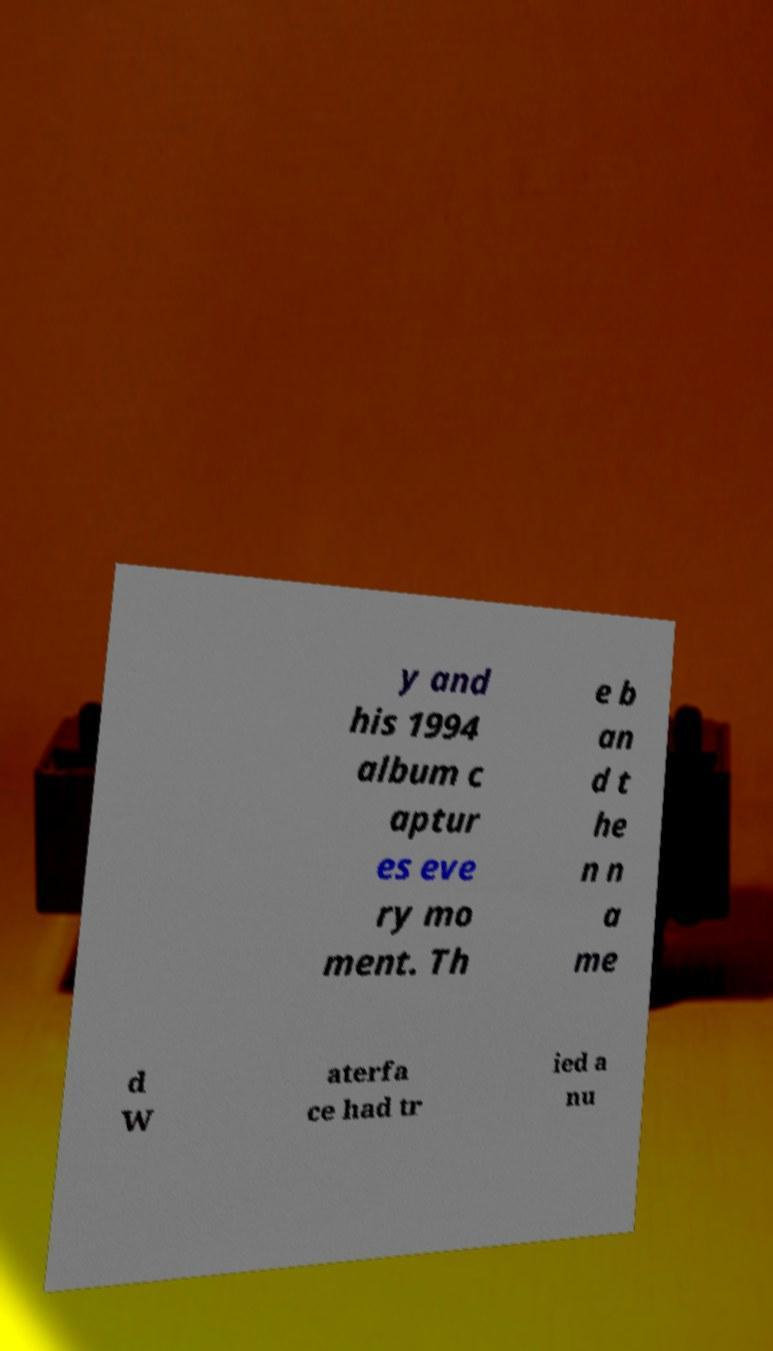Can you read and provide the text displayed in the image?This photo seems to have some interesting text. Can you extract and type it out for me? y and his 1994 album c aptur es eve ry mo ment. Th e b an d t he n n a me d W aterfa ce had tr ied a nu 